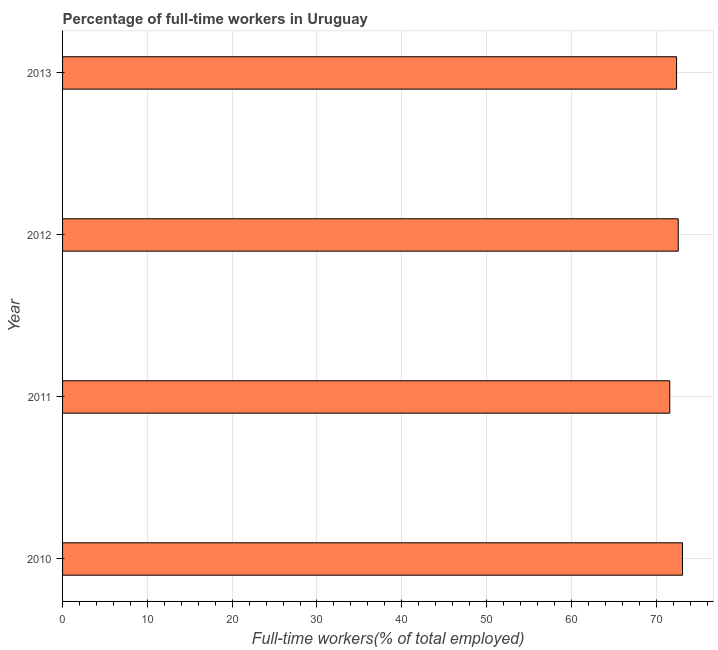What is the title of the graph?
Make the answer very short. Percentage of full-time workers in Uruguay. What is the label or title of the X-axis?
Your response must be concise. Full-time workers(% of total employed). What is the percentage of full-time workers in 2013?
Your answer should be very brief. 72.4. Across all years, what is the maximum percentage of full-time workers?
Give a very brief answer. 73.1. Across all years, what is the minimum percentage of full-time workers?
Offer a terse response. 71.6. What is the sum of the percentage of full-time workers?
Keep it short and to the point. 289.7. What is the average percentage of full-time workers per year?
Keep it short and to the point. 72.42. What is the median percentage of full-time workers?
Your response must be concise. 72.5. In how many years, is the percentage of full-time workers greater than 16 %?
Your answer should be compact. 4. What is the ratio of the percentage of full-time workers in 2011 to that in 2013?
Provide a succinct answer. 0.99. Is the difference between the percentage of full-time workers in 2011 and 2013 greater than the difference between any two years?
Your answer should be very brief. No. Is the sum of the percentage of full-time workers in 2010 and 2012 greater than the maximum percentage of full-time workers across all years?
Make the answer very short. Yes. In how many years, is the percentage of full-time workers greater than the average percentage of full-time workers taken over all years?
Offer a very short reply. 2. How many bars are there?
Provide a succinct answer. 4. Are all the bars in the graph horizontal?
Offer a very short reply. Yes. How many years are there in the graph?
Offer a terse response. 4. What is the difference between two consecutive major ticks on the X-axis?
Offer a very short reply. 10. What is the Full-time workers(% of total employed) of 2010?
Provide a short and direct response. 73.1. What is the Full-time workers(% of total employed) in 2011?
Ensure brevity in your answer.  71.6. What is the Full-time workers(% of total employed) of 2012?
Offer a terse response. 72.6. What is the Full-time workers(% of total employed) of 2013?
Offer a terse response. 72.4. What is the difference between the Full-time workers(% of total employed) in 2010 and 2011?
Provide a short and direct response. 1.5. What is the difference between the Full-time workers(% of total employed) in 2010 and 2013?
Provide a short and direct response. 0.7. What is the difference between the Full-time workers(% of total employed) in 2012 and 2013?
Offer a terse response. 0.2. What is the ratio of the Full-time workers(% of total employed) in 2010 to that in 2011?
Ensure brevity in your answer.  1.02. What is the ratio of the Full-time workers(% of total employed) in 2010 to that in 2012?
Ensure brevity in your answer.  1.01. What is the ratio of the Full-time workers(% of total employed) in 2010 to that in 2013?
Provide a succinct answer. 1.01. What is the ratio of the Full-time workers(% of total employed) in 2011 to that in 2013?
Make the answer very short. 0.99. 